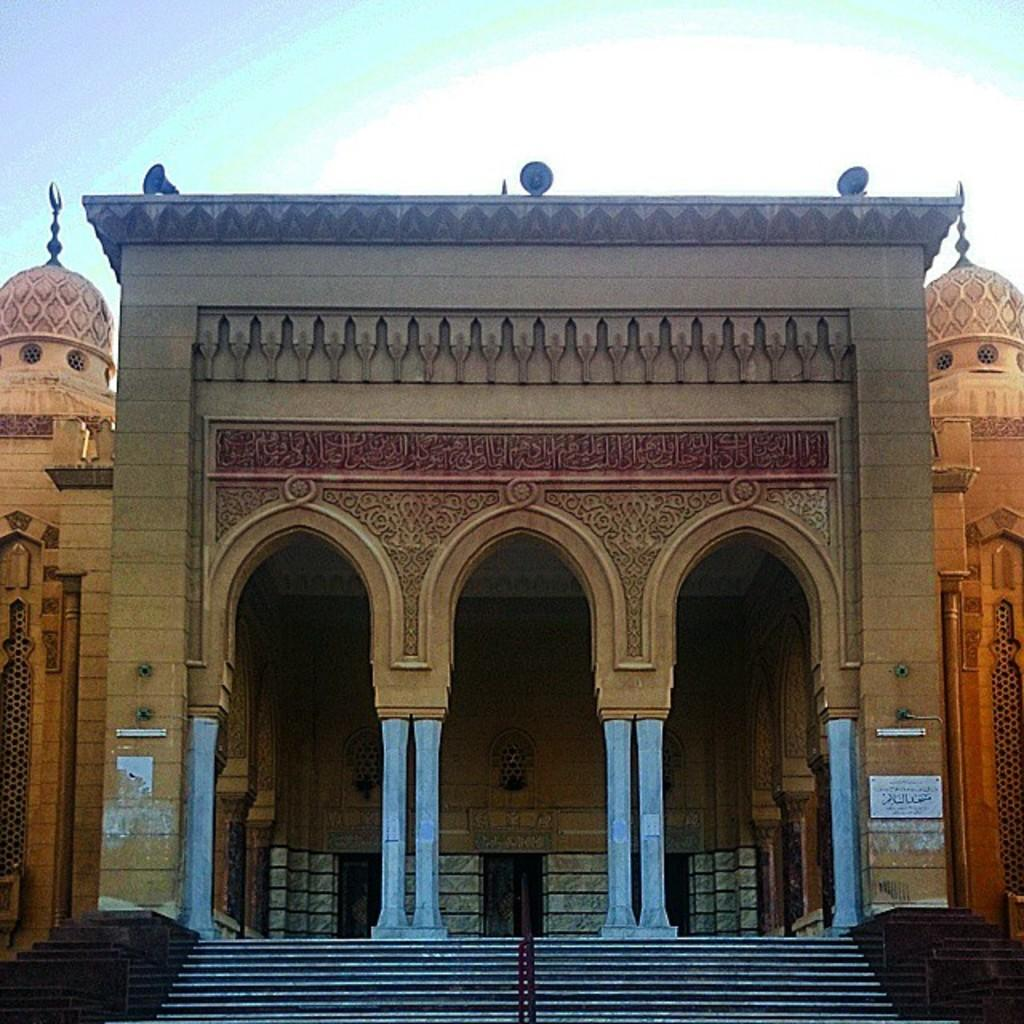What type of structures can be seen in the image? There are buildings in the image. Are there any architectural features visible in the image? Yes, there are staircases in the image. What type of canvas is used to paint the buildings in the image? There is no canvas present in the image, as it is a photograph or digital representation of the buildings. Who is the owner of the bottle seen in the image? There is no bottle present in the image, so it is not possible to determine the owner. 